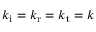<formula> <loc_0><loc_0><loc_500><loc_500>k _ { i } = k _ { r } = k _ { t } = k</formula> 